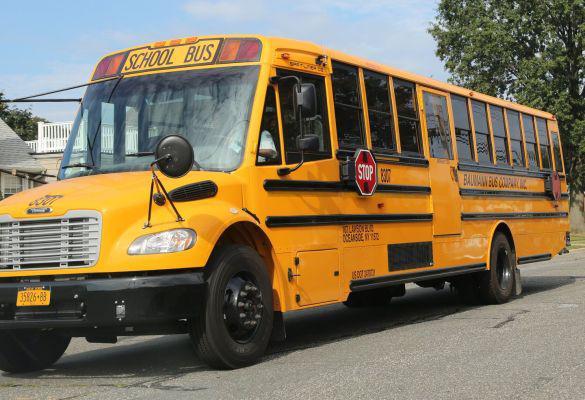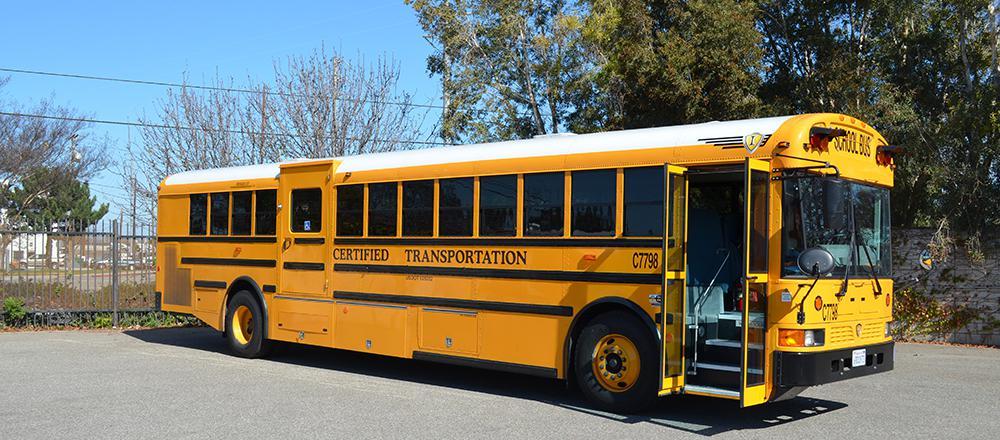The first image is the image on the left, the second image is the image on the right. Assess this claim about the two images: "At least one bus' doors are open.". Correct or not? Answer yes or no. Yes. The first image is the image on the left, the second image is the image on the right. Analyze the images presented: Is the assertion "The two school buses are facing nearly opposite directions." valid? Answer yes or no. Yes. 